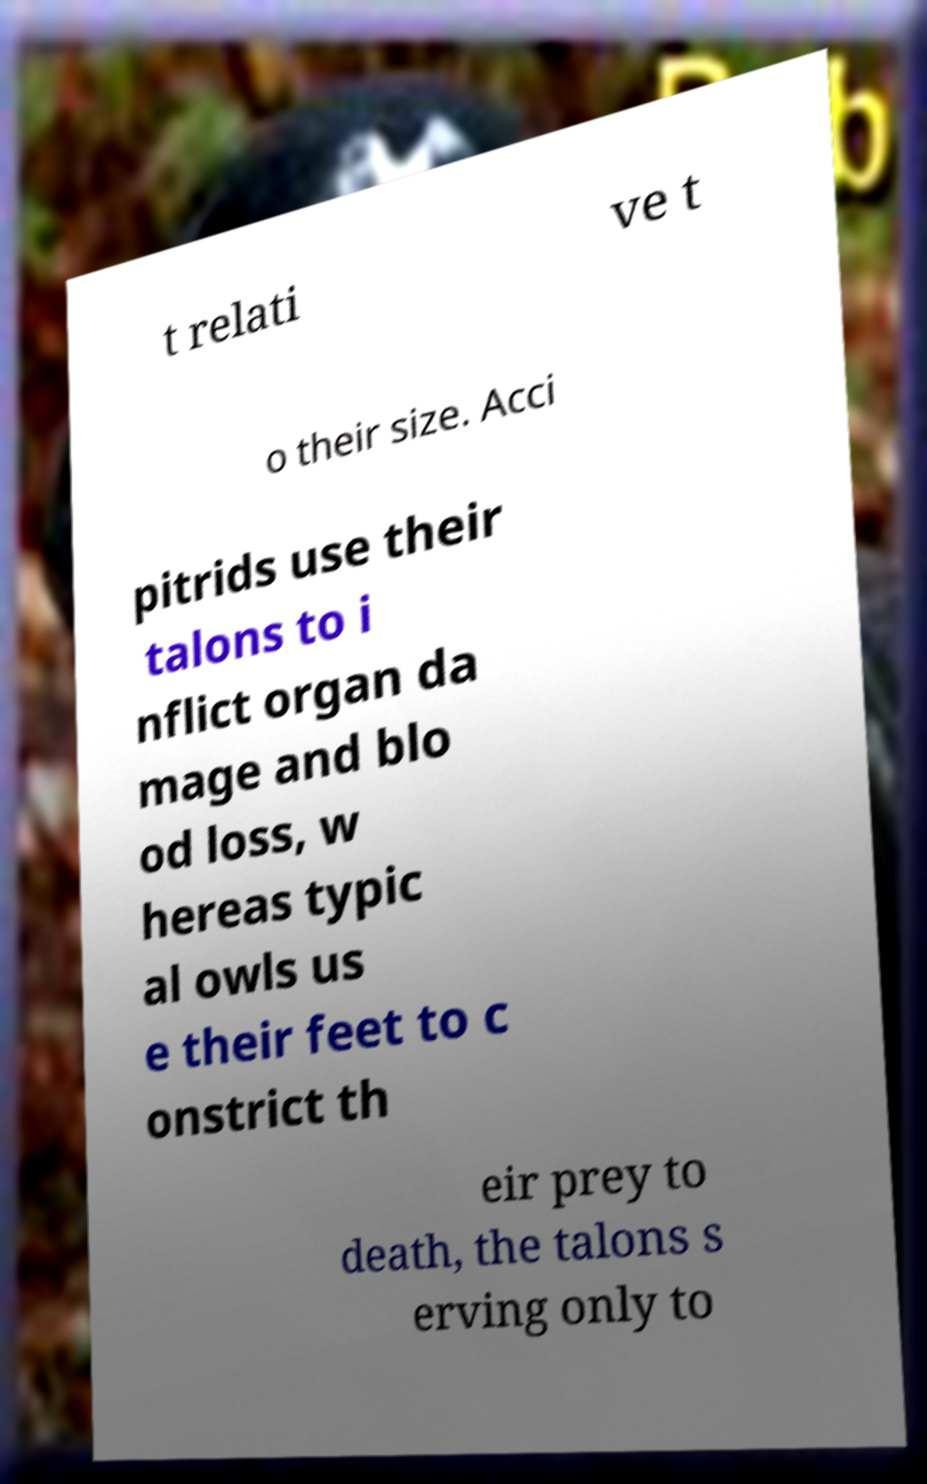Please read and relay the text visible in this image. What does it say? t relati ve t o their size. Acci pitrids use their talons to i nflict organ da mage and blo od loss, w hereas typic al owls us e their feet to c onstrict th eir prey to death, the talons s erving only to 